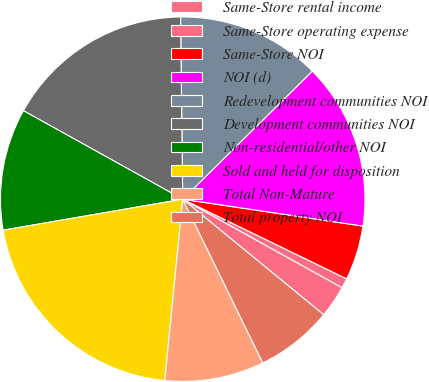<chart> <loc_0><loc_0><loc_500><loc_500><pie_chart><fcel>Same-Store rental income<fcel>Same-Store operating expense<fcel>Same-Store NOI<fcel>NOI (d)<fcel>Redevelopment communities NOI<fcel>Development communities NOI<fcel>Non-residential/other NOI<fcel>Sold and held for disposition<fcel>Total Non-Mature<fcel>Total property NOI<nl><fcel>2.86%<fcel>0.87%<fcel>4.84%<fcel>14.76%<fcel>12.78%<fcel>16.74%<fcel>10.79%<fcel>20.71%<fcel>8.81%<fcel>6.83%<nl></chart> 